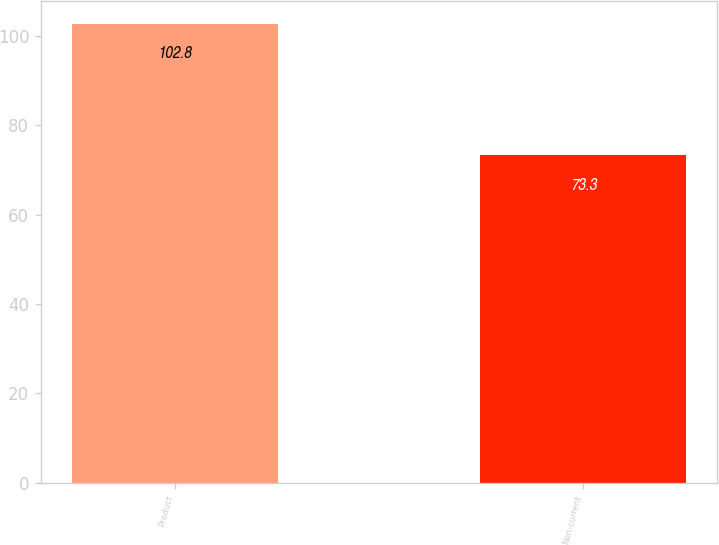<chart> <loc_0><loc_0><loc_500><loc_500><bar_chart><fcel>Product<fcel>Non-current<nl><fcel>102.8<fcel>73.3<nl></chart> 